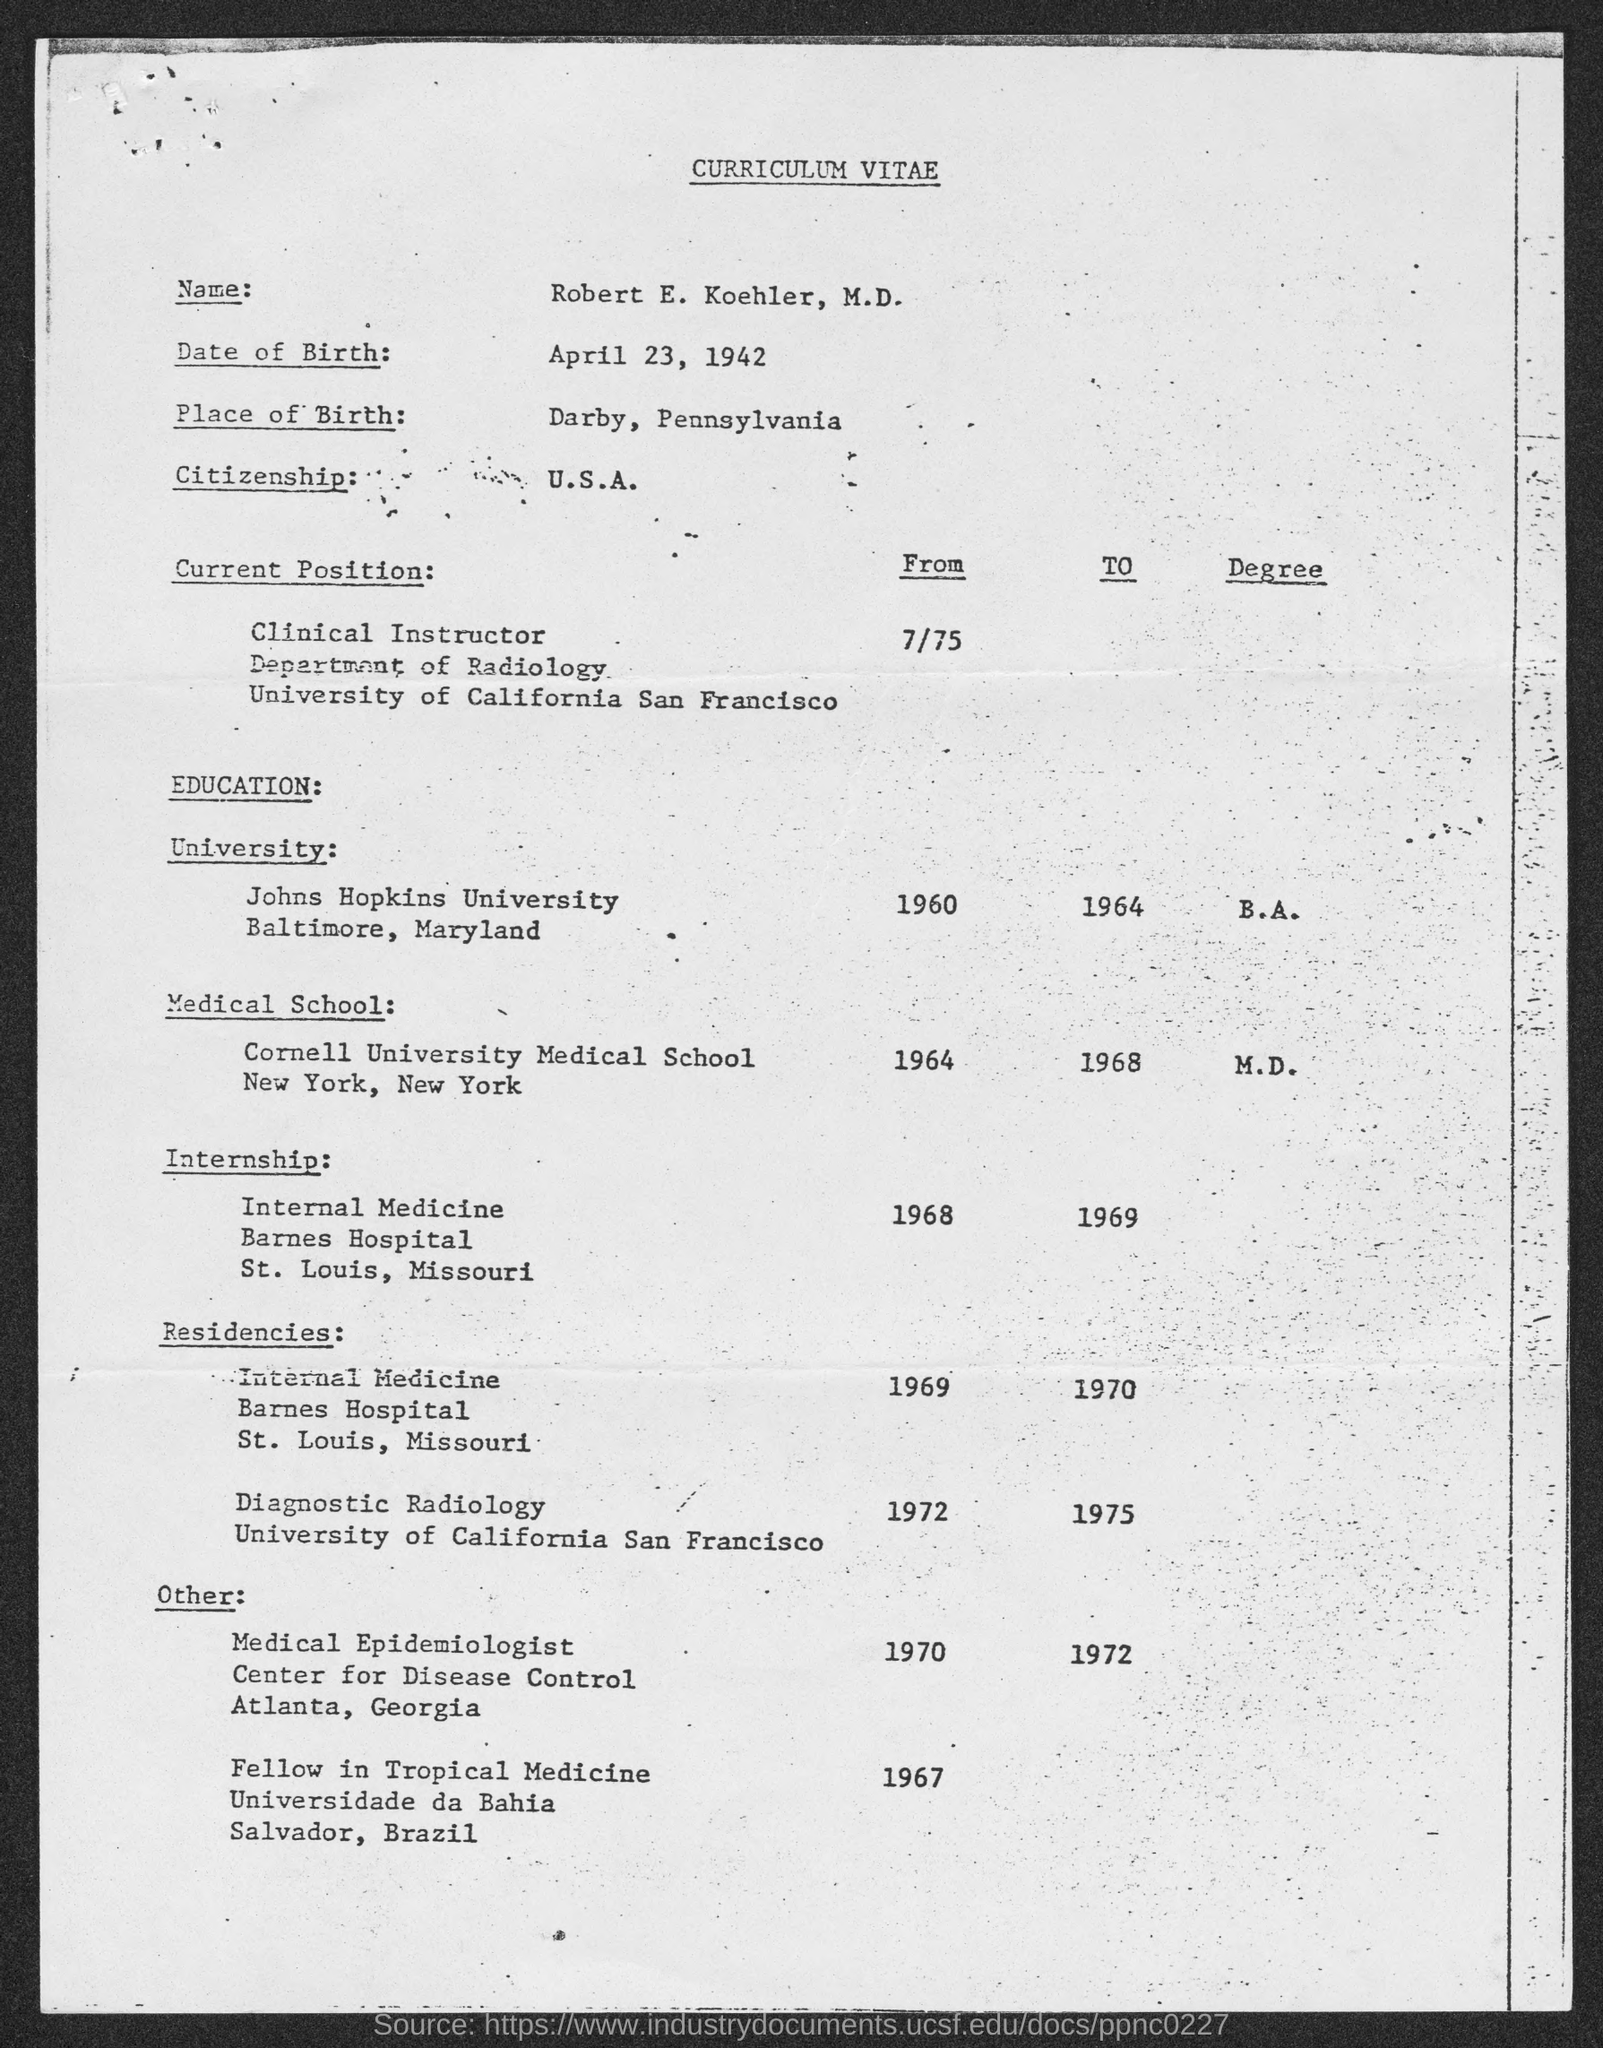Who's curriculum vitae is given here?
Your answer should be very brief. Robert E. Koehler, M.D. What is the date of birth of Robert E. Koehler, M.D.?
Your response must be concise. April 23, 1942. Which is the birth place of Robert E. Koehler, M.D.?
Your response must be concise. Darby, Pennsylvania. What is the citizenship of Robert E. Koehler, M.D.?
Offer a very short reply. U.S.A. In which university, Robert E. Koehler, M.D. completed his B.A. degree?
Keep it short and to the point. Johns Hopkins University. When did Robert E. Koehler, M.D. completed his M.D. degree from Cornell University Medical School?
Your response must be concise. 1968. 